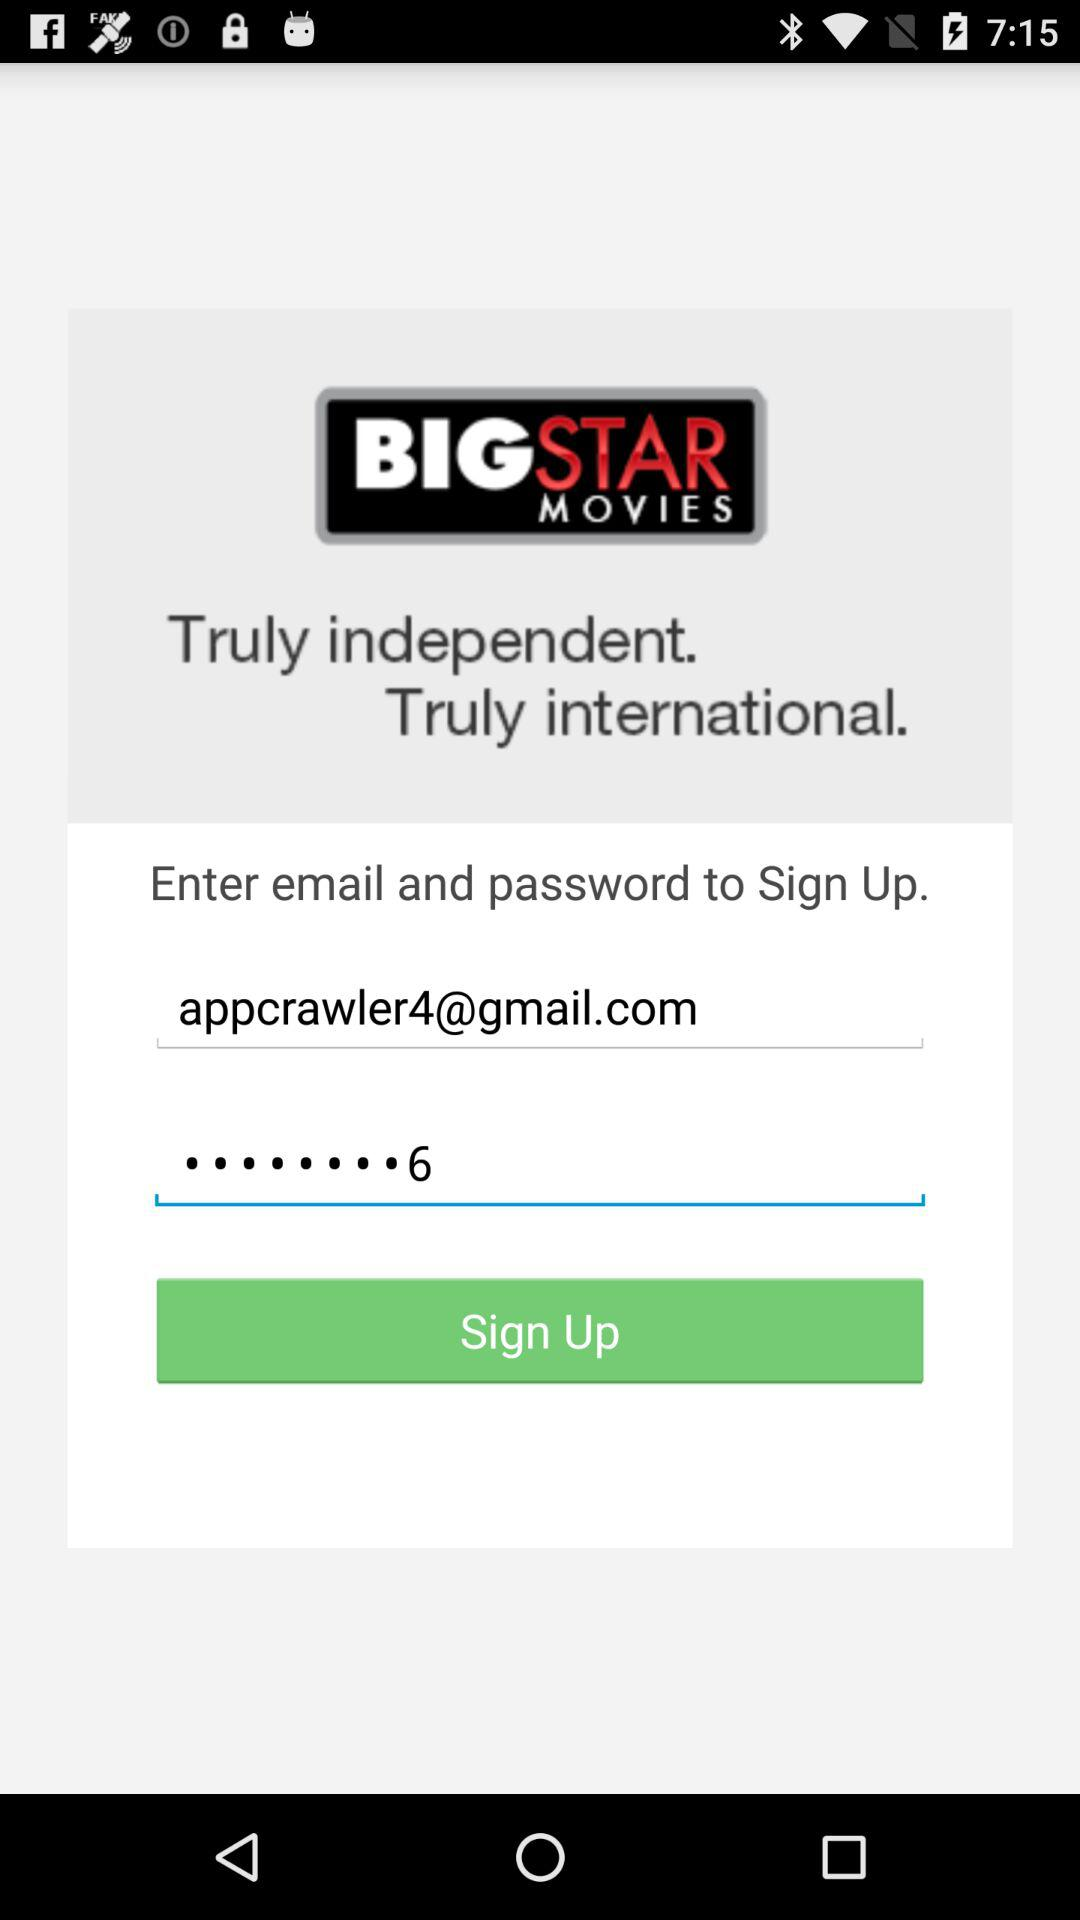How many text fields are there in the sign up form?
Answer the question using a single word or phrase. 2 